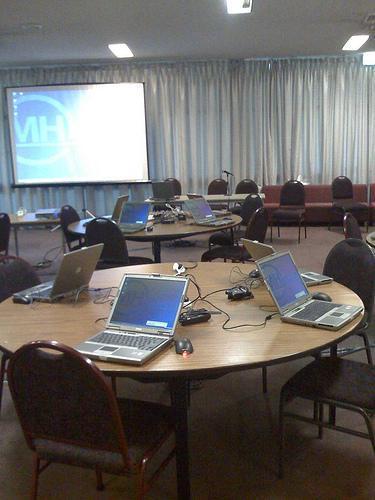How many projector screens are in the photo?
Give a very brief answer. 1. 